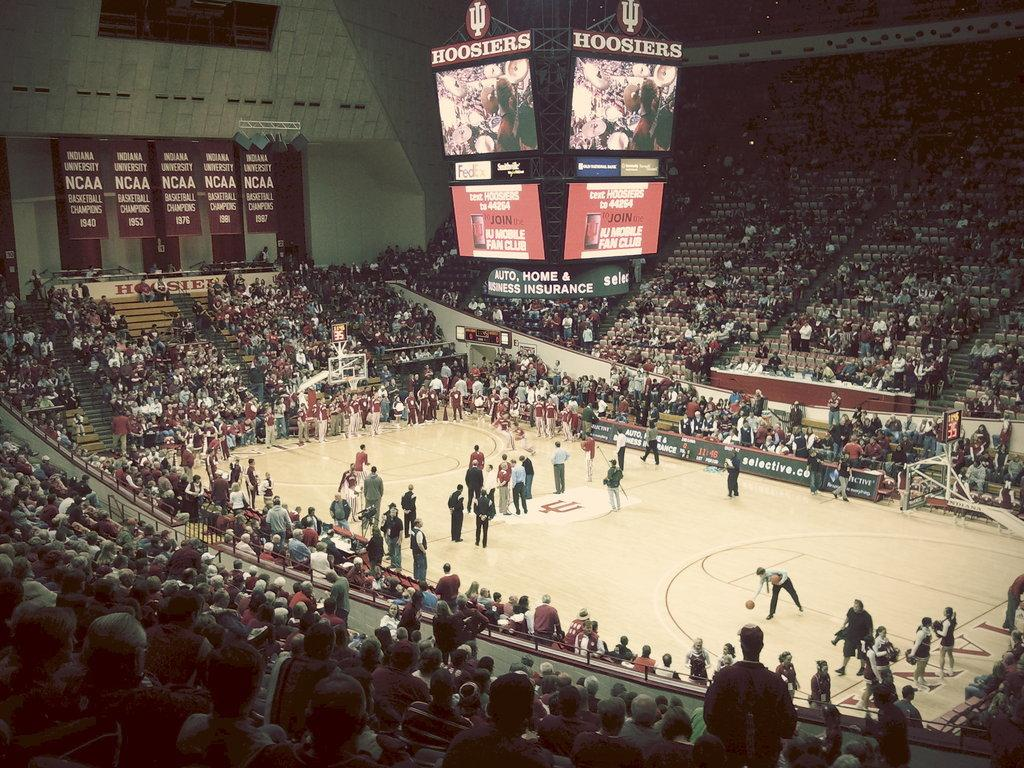What is the main setting of the image? The main setting of the image is a stadium. What can be seen in the background of the image? There are boards and a crowd visible in the background. How many people are present in the image? There are people standing in the stadium, but the exact number is not specified. Can you see any goldfish in the image? No, there are no goldfish present in the image. 